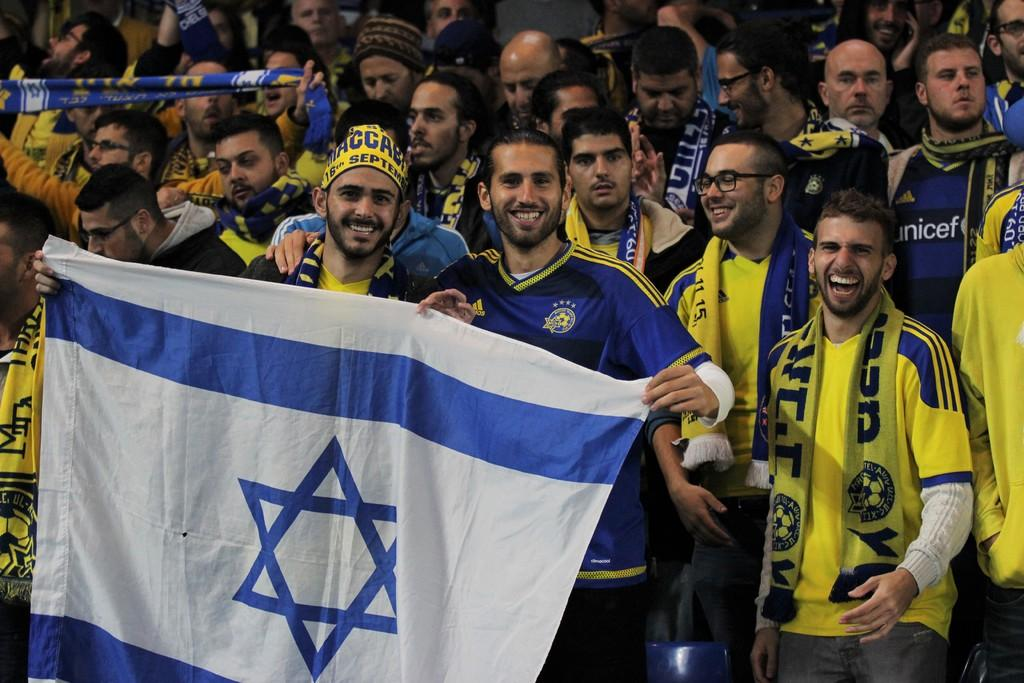How many people are in the image? There is a group of people in the image. Can you describe the clothing of one of the individuals? One person is wearing a blue t-shirt and holding a flag. What can be seen on another person in the image? One person is wearing spectacles and a yellow t-shirt. What type of breakfast is being served in the image? There is no breakfast present in the image; it features a group of people. Can you describe the cap worn by one of the individuals in the image? There is no cap mentioned in the image; only a blue t-shirt and a yellow t-shirt are described. 